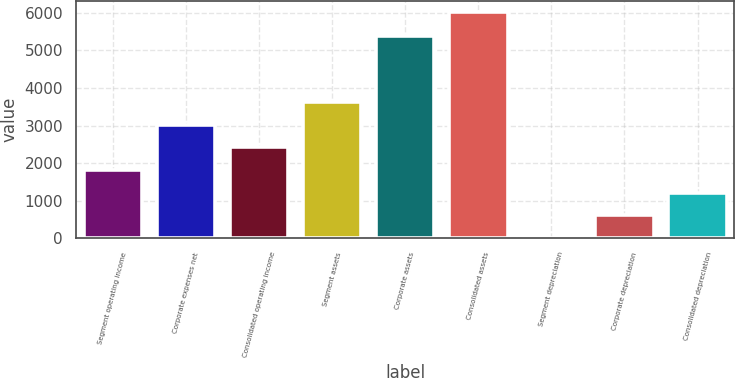<chart> <loc_0><loc_0><loc_500><loc_500><bar_chart><fcel>Segment operating income<fcel>Corporate expenses net<fcel>Consolidated operating income<fcel>Segment assets<fcel>Corporate assets<fcel>Consolidated assets<fcel>Segment depreciation<fcel>Corporate depreciation<fcel>Consolidated depreciation<nl><fcel>1817.5<fcel>3018.5<fcel>2418<fcel>3619<fcel>5390<fcel>6021<fcel>16<fcel>616.5<fcel>1217<nl></chart> 